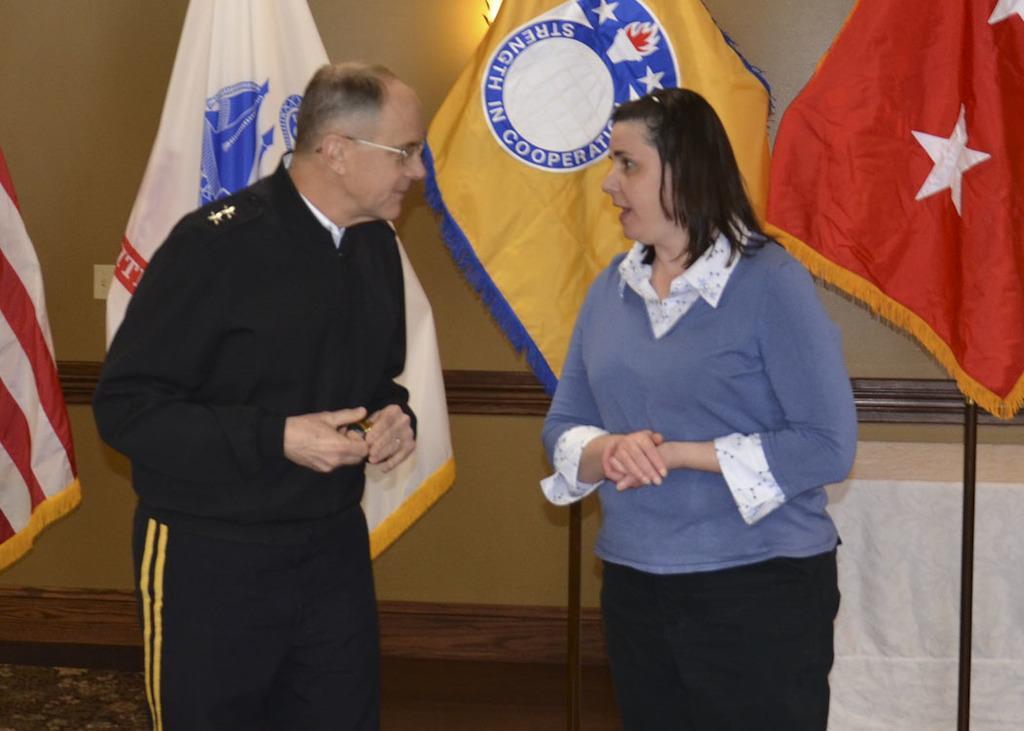Describe this image in one or two sentences. In this image I can see two people with different color dresses. In the background I can see the colorful flags and I can see the wall. 